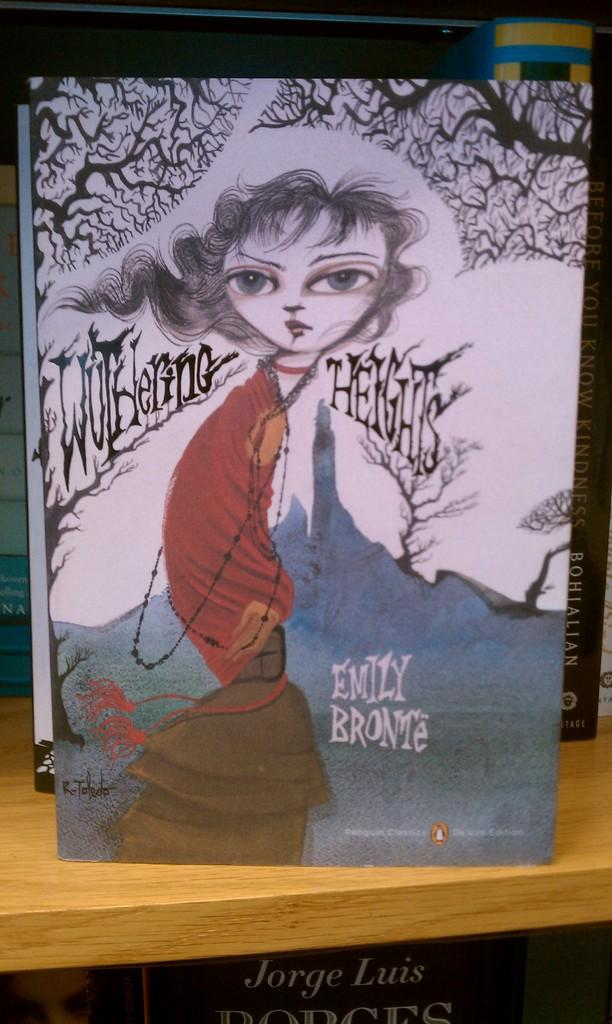<image>
Relay a brief, clear account of the picture shown. A copy of the book Wuthering Heights by Emily Bronte 